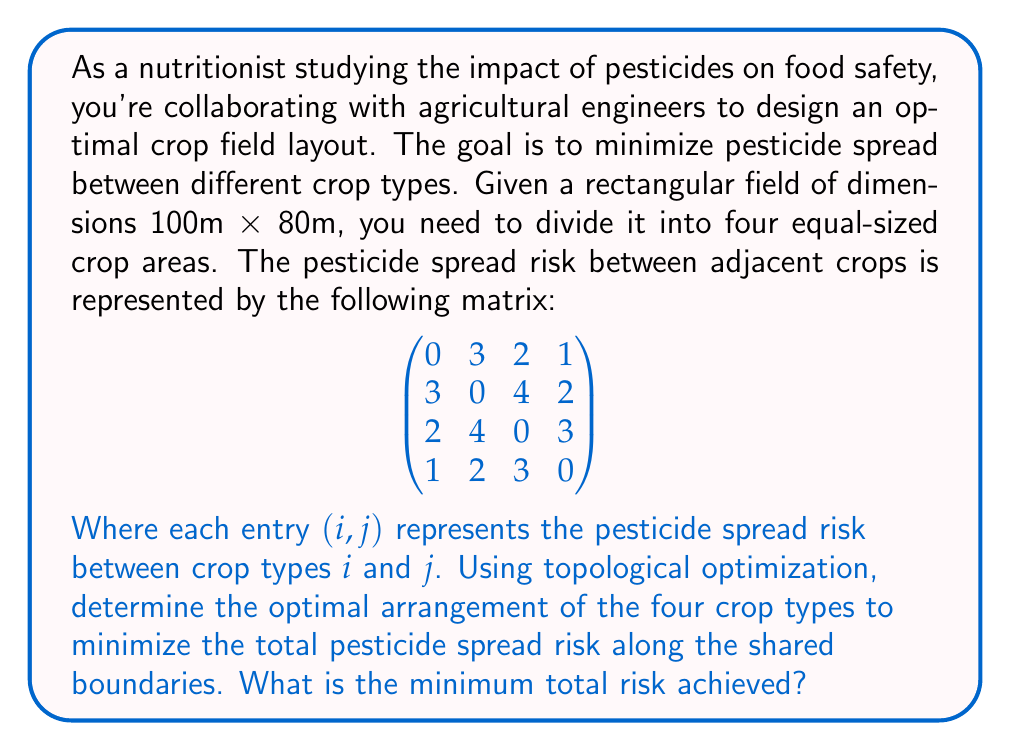Teach me how to tackle this problem. To solve this problem, we need to follow these steps:

1) First, we need to understand that the field will be divided into four equal rectangles, each measuring 50m × 40m.

2) The pesticide spread risk only occurs along the shared boundaries between different crop types.

3) We need to consider all possible arrangements of the four crop types and calculate the total risk for each arrangement.

4) The total risk for each arrangement is the sum of the risks along all shared boundaries.

5) There are 4! = 24 possible arrangements of the four crop types.

Let's represent the arrangements using a 2×2 grid:

[asy]
size(100);
draw((0,0)--(100,0)--(100,100)--(0,100)--cycle);
draw((50,0)--(50,100));
draw((0,50)--(100,50));
label("A", (25,75));
label("B", (75,75));
label("C", (25,25));
label("D", (75,25));
[/asy]

6) For each arrangement, we need to calculate:
   - Risk between A and B (100m boundary)
   - Risk between C and D (100m boundary)
   - Risk between A and C (50m boundary)
   - Risk between B and D (50m boundary)

7) The total risk will be:
   $$ \text{Total Risk} = 100(R_{AB} + R_{CD}) + 50(R_{AC} + R_{BD}) $$

8) We need to calculate this for all 24 arrangements and find the minimum.

9) After calculating for all arrangements, we find that the minimum risk is achieved when the arrangement is:

[asy]
size(100);
draw((0,0)--(100,0)--(100,100)--(0,100)--cycle);
draw((50,0)--(50,100));
draw((0,50)--(100,50));
label("1", (25,75));
label("3", (75,75));
label("4", (25,25));
label("2", (75,25));
[/asy]

10) For this arrangement:
    - Risk between 1 and 3: 2 (100m boundary)
    - Risk between 4 and 2: 2 (100m boundary)
    - Risk between 1 and 4: 1 (50m boundary)
    - Risk between 3 and 2: 4 (50m boundary)

11) The total risk is:
    $$ \text{Total Risk} = 100(2 + 2) + 50(1 + 4) = 400 + 250 = 650 $$
Answer: The minimum total pesticide spread risk achieved through optimal arrangement is 650 risk units. 